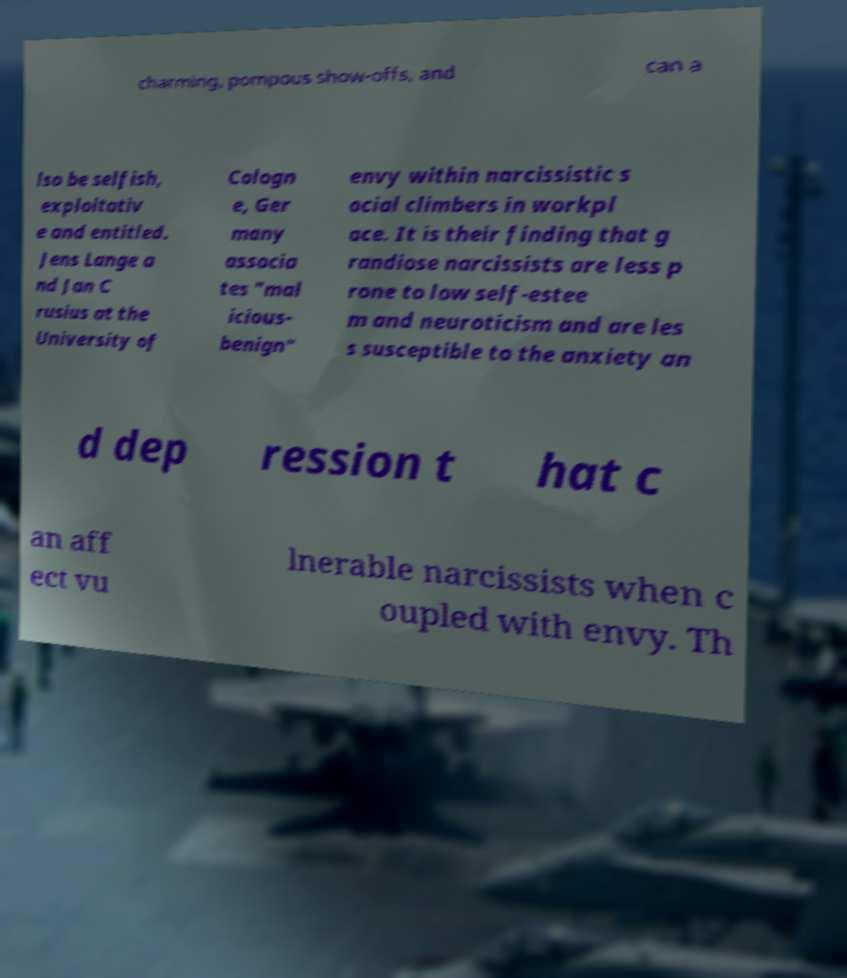Could you assist in decoding the text presented in this image and type it out clearly? charming, pompous show-offs, and can a lso be selfish, exploitativ e and entitled. Jens Lange a nd Jan C rusius at the University of Cologn e, Ger many associa tes "mal icious- benign" envy within narcissistic s ocial climbers in workpl ace. It is their finding that g randiose narcissists are less p rone to low self-estee m and neuroticism and are les s susceptible to the anxiety an d dep ression t hat c an aff ect vu lnerable narcissists when c oupled with envy. Th 